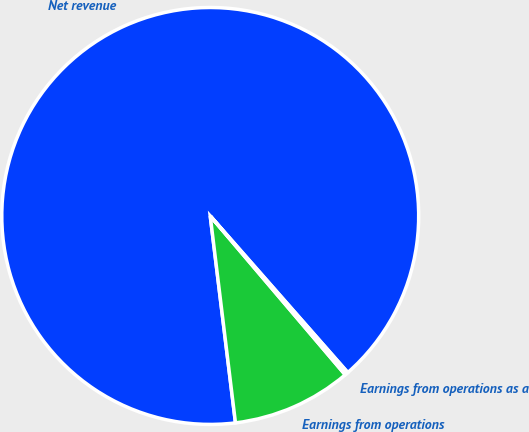Convert chart to OTSL. <chart><loc_0><loc_0><loc_500><loc_500><pie_chart><fcel>Net revenue<fcel>Earnings from operations<fcel>Earnings from operations as a<nl><fcel>90.46%<fcel>9.28%<fcel>0.26%<nl></chart> 